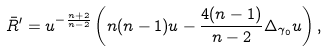Convert formula to latex. <formula><loc_0><loc_0><loc_500><loc_500>\bar { R } ^ { \prime } = u ^ { - \frac { n + 2 } { n - 2 } } \left ( n ( n - 1 ) u - \frac { 4 ( n - 1 ) } { n - 2 } \Delta _ { \gamma _ { 0 } } u \right ) ,</formula> 